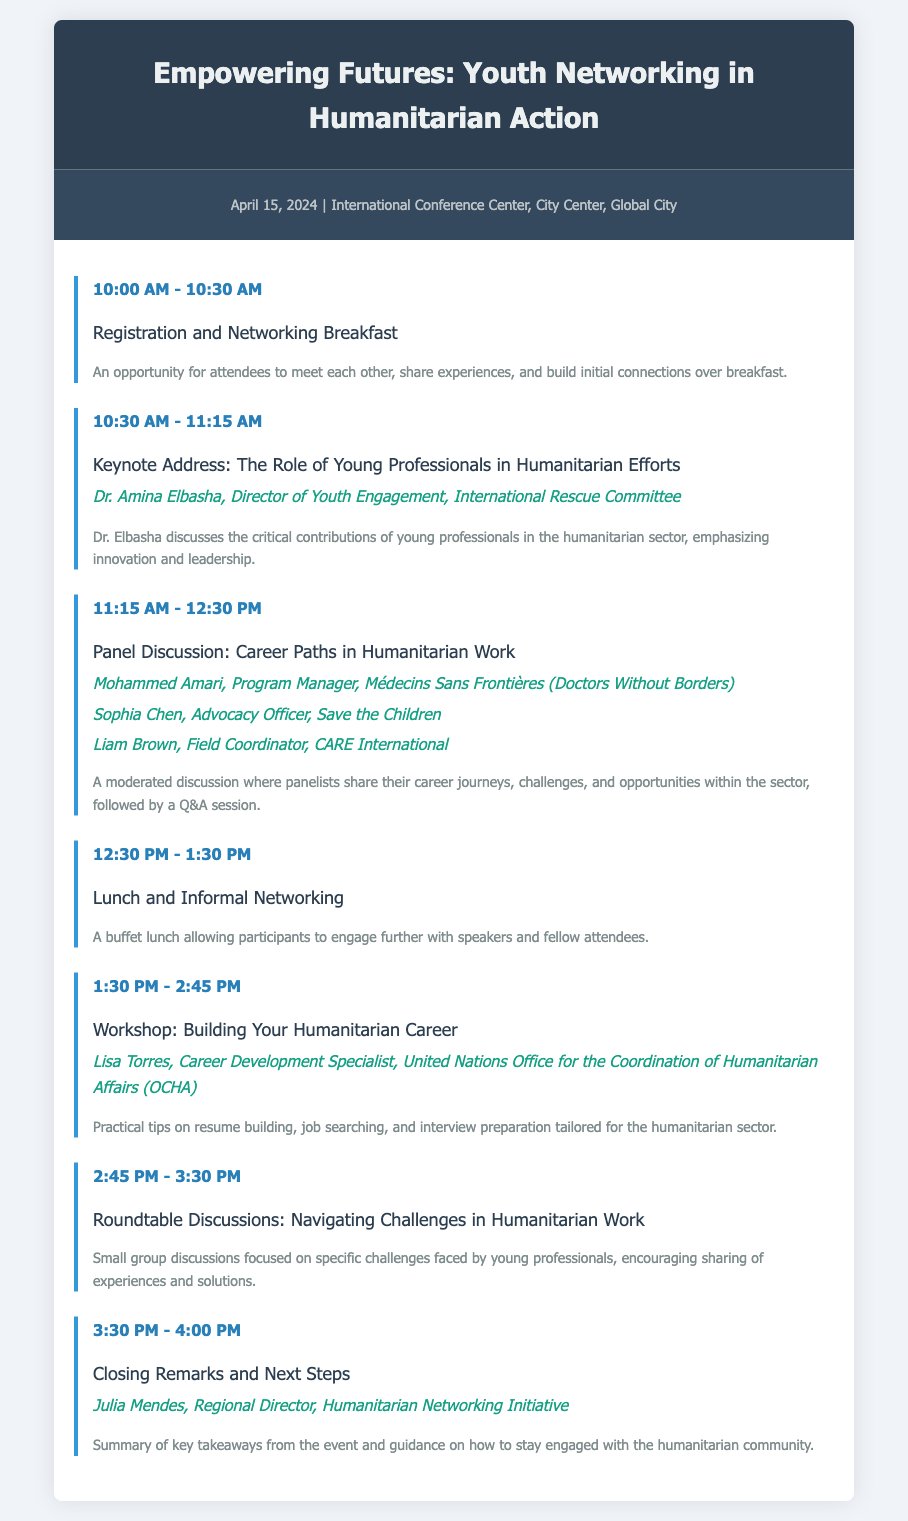what is the date of the event? The document specifies that the event will take place on April 15, 2024.
Answer: April 15, 2024 who is the keynote speaker? The agenda lists Dr. Amina Elbasha as the keynote speaker.
Answer: Dr. Amina Elbasha how long is the panel discussion scheduled for? The agenda indicates that the panel discussion will last for 1 hour and 15 minutes.
Answer: 1 hour and 15 minutes which organization does Mohammed Amari represent? Mohammed Amari is identified as a Program Manager at Médecins Sans Frontières.
Answer: Médecins Sans Frontières what session follows the lunch break? The session following lunch is a workshop titled "Building Your Humanitarian Career."
Answer: Building Your Humanitarian Career who will deliver the closing remarks? The document states that Julia Mendes will deliver the closing remarks.
Answer: Julia Mendes how many panelists are featured in the career paths discussion? The document lists three panelists participating in the discussion.
Answer: Three what is the purpose of the roundtable discussions? The roundtable discussions are focused on navigating challenges in humanitarian work.
Answer: Navigating challenges in humanitarian work what time does the event start? The agenda shows that the registration opens at 10:00 AM.
Answer: 10:00 AM 